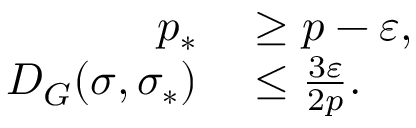<formula> <loc_0><loc_0><loc_500><loc_500>\begin{array} { r l } { p _ { \ast } } & \geq p - \varepsilon , } \\ { D _ { G } ( \sigma , \sigma _ { \ast } ) } & \leq \frac { 3 \varepsilon } { 2 p } . } \end{array}</formula> 